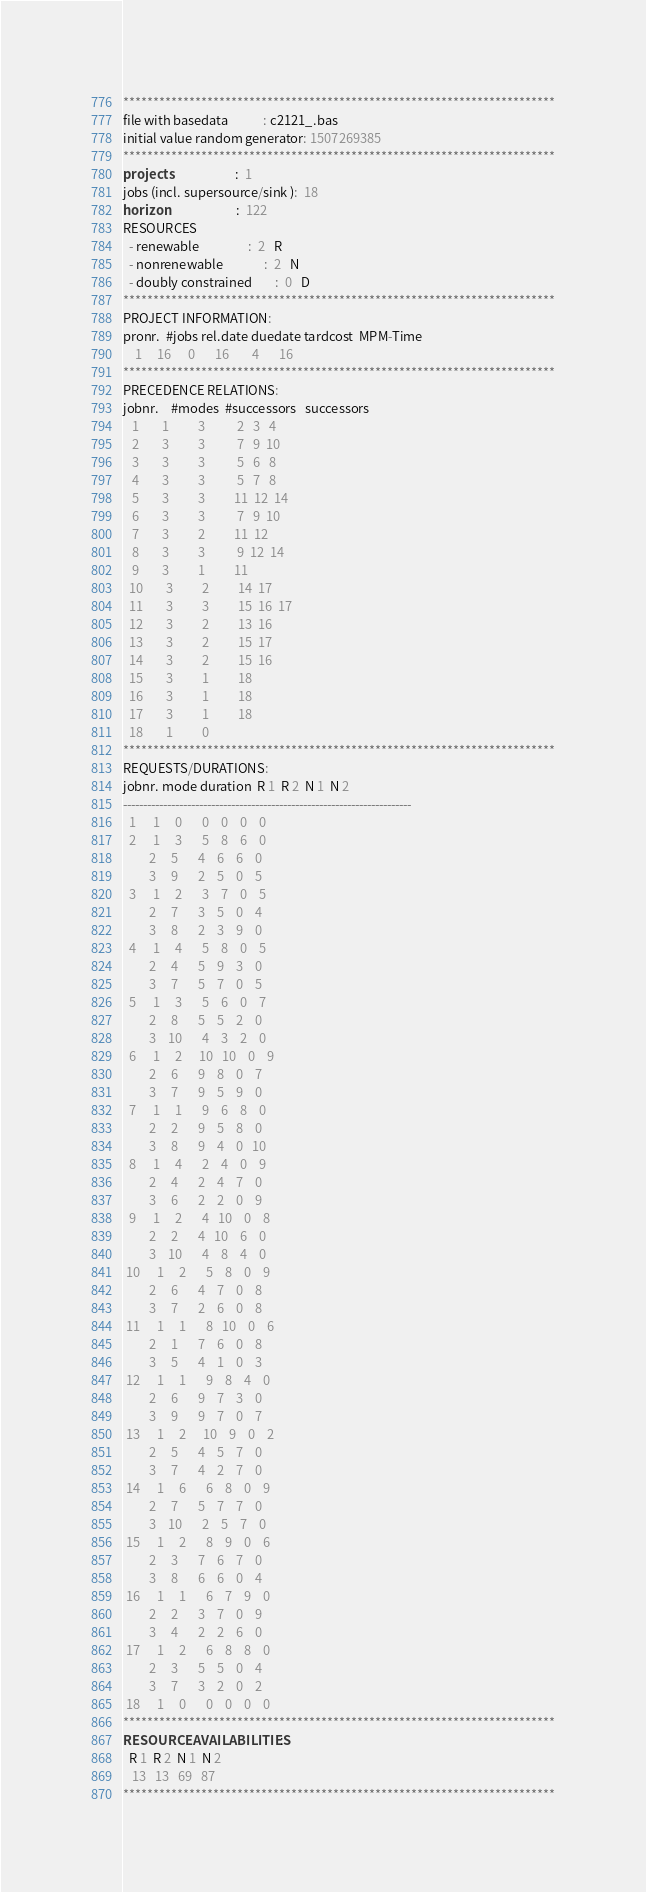<code> <loc_0><loc_0><loc_500><loc_500><_ObjectiveC_>************************************************************************
file with basedata            : c2121_.bas
initial value random generator: 1507269385
************************************************************************
projects                      :  1
jobs (incl. supersource/sink ):  18
horizon                       :  122
RESOURCES
  - renewable                 :  2   R
  - nonrenewable              :  2   N
  - doubly constrained        :  0   D
************************************************************************
PROJECT INFORMATION:
pronr.  #jobs rel.date duedate tardcost  MPM-Time
    1     16      0       16        4       16
************************************************************************
PRECEDENCE RELATIONS:
jobnr.    #modes  #successors   successors
   1        1          3           2   3   4
   2        3          3           7   9  10
   3        3          3           5   6   8
   4        3          3           5   7   8
   5        3          3          11  12  14
   6        3          3           7   9  10
   7        3          2          11  12
   8        3          3           9  12  14
   9        3          1          11
  10        3          2          14  17
  11        3          3          15  16  17
  12        3          2          13  16
  13        3          2          15  17
  14        3          2          15  16
  15        3          1          18
  16        3          1          18
  17        3          1          18
  18        1          0        
************************************************************************
REQUESTS/DURATIONS:
jobnr. mode duration  R 1  R 2  N 1  N 2
------------------------------------------------------------------------
  1      1     0       0    0    0    0
  2      1     3       5    8    6    0
         2     5       4    6    6    0
         3     9       2    5    0    5
  3      1     2       3    7    0    5
         2     7       3    5    0    4
         3     8       2    3    9    0
  4      1     4       5    8    0    5
         2     4       5    9    3    0
         3     7       5    7    0    5
  5      1     3       5    6    0    7
         2     8       5    5    2    0
         3    10       4    3    2    0
  6      1     2      10   10    0    9
         2     6       9    8    0    7
         3     7       9    5    9    0
  7      1     1       9    6    8    0
         2     2       9    5    8    0
         3     8       9    4    0   10
  8      1     4       2    4    0    9
         2     4       2    4    7    0
         3     6       2    2    0    9
  9      1     2       4   10    0    8
         2     2       4   10    6    0
         3    10       4    8    4    0
 10      1     2       5    8    0    9
         2     6       4    7    0    8
         3     7       2    6    0    8
 11      1     1       8   10    0    6
         2     1       7    6    0    8
         3     5       4    1    0    3
 12      1     1       9    8    4    0
         2     6       9    7    3    0
         3     9       9    7    0    7
 13      1     2      10    9    0    2
         2     5       4    5    7    0
         3     7       4    2    7    0
 14      1     6       6    8    0    9
         2     7       5    7    7    0
         3    10       2    5    7    0
 15      1     2       8    9    0    6
         2     3       7    6    7    0
         3     8       6    6    0    4
 16      1     1       6    7    9    0
         2     2       3    7    0    9
         3     4       2    2    6    0
 17      1     2       6    8    8    0
         2     3       5    5    0    4
         3     7       3    2    0    2
 18      1     0       0    0    0    0
************************************************************************
RESOURCEAVAILABILITIES:
  R 1  R 2  N 1  N 2
   13   13   69   87
************************************************************************
</code> 